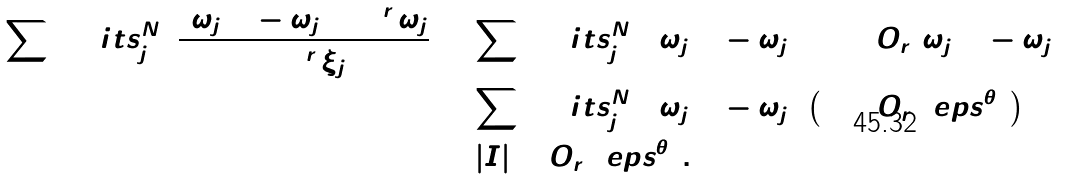<formula> <loc_0><loc_0><loc_500><loc_500>\sum \lim i t s _ { j = 1 } ^ { N } \frac { ( \omega _ { j + 1 } - \omega _ { j } ) \cos ^ { r } \omega _ { j } } { \cos ^ { r } \xi _ { j } } & = \sum \lim i t s _ { j = 1 } ^ { N } ( \omega _ { j + 1 } - \omega _ { j } ) \left ( 1 + O _ { r } ( \omega _ { j + 1 } - \omega _ { j } ) \right ) \\ & = \sum \lim i t s _ { j = 1 } ^ { N } ( \omega _ { j + 1 } - \omega _ { j } ) \left ( 1 + O _ { r } ( \ e p s ^ { \theta } ) \right ) \\ & = | I | + O _ { r } ( \ e p s ^ { \theta } ) .</formula> 